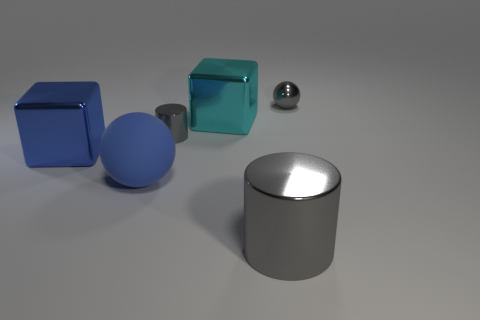Add 2 blocks. How many objects exist? 8 Subtract all blocks. How many objects are left? 4 Subtract 1 balls. How many balls are left? 1 Add 1 small gray metallic spheres. How many small gray metallic spheres are left? 2 Add 5 small green things. How many small green things exist? 5 Subtract 0 gray blocks. How many objects are left? 6 Subtract all purple cubes. Subtract all purple spheres. How many cubes are left? 2 Subtract all blue blocks. How many yellow cylinders are left? 0 Subtract all small brown metallic blocks. Subtract all gray shiny cylinders. How many objects are left? 4 